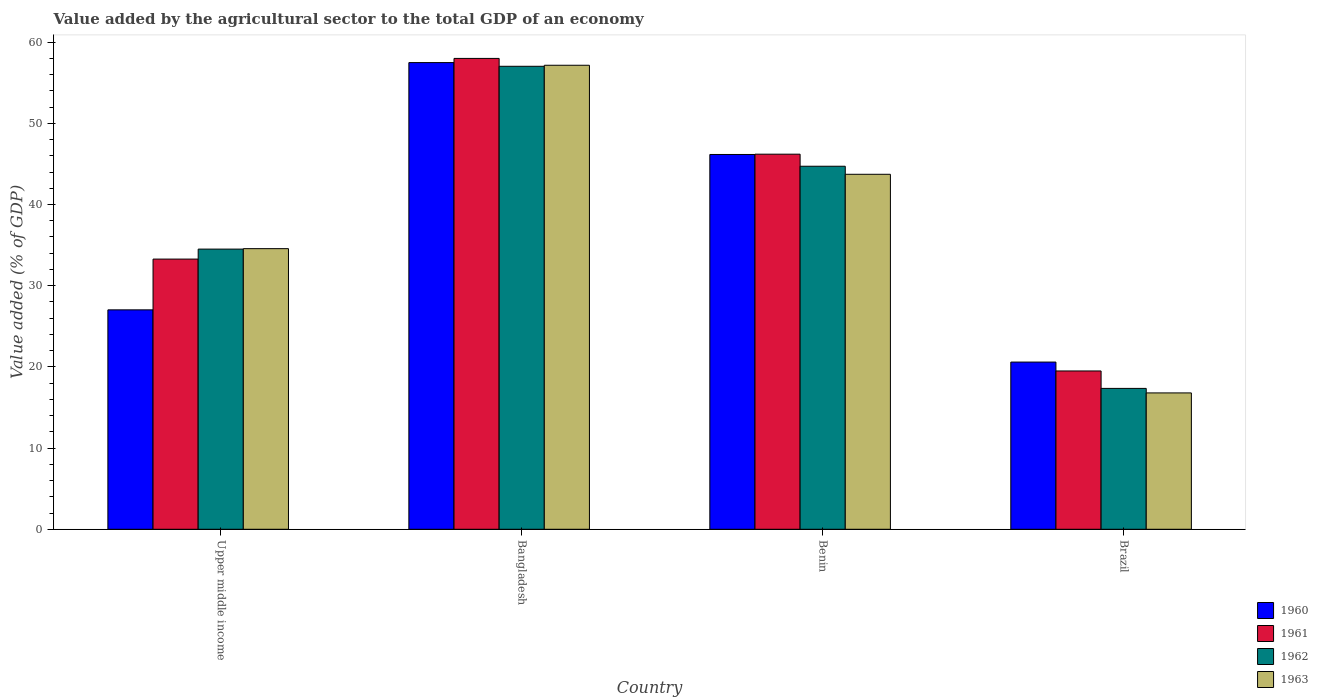Are the number of bars per tick equal to the number of legend labels?
Offer a very short reply. Yes. Are the number of bars on each tick of the X-axis equal?
Provide a succinct answer. Yes. How many bars are there on the 3rd tick from the left?
Your response must be concise. 4. What is the label of the 2nd group of bars from the left?
Offer a terse response. Bangladesh. In how many cases, is the number of bars for a given country not equal to the number of legend labels?
Offer a very short reply. 0. What is the value added by the agricultural sector to the total GDP in 1960 in Brazil?
Your answer should be very brief. 20.59. Across all countries, what is the maximum value added by the agricultural sector to the total GDP in 1963?
Keep it short and to the point. 57.15. Across all countries, what is the minimum value added by the agricultural sector to the total GDP in 1961?
Offer a terse response. 19.5. In which country was the value added by the agricultural sector to the total GDP in 1961 minimum?
Ensure brevity in your answer.  Brazil. What is the total value added by the agricultural sector to the total GDP in 1961 in the graph?
Provide a short and direct response. 156.95. What is the difference between the value added by the agricultural sector to the total GDP in 1963 in Brazil and that in Upper middle income?
Keep it short and to the point. -17.77. What is the difference between the value added by the agricultural sector to the total GDP in 1961 in Benin and the value added by the agricultural sector to the total GDP in 1962 in Brazil?
Keep it short and to the point. 28.84. What is the average value added by the agricultural sector to the total GDP in 1963 per country?
Your response must be concise. 38.05. What is the difference between the value added by the agricultural sector to the total GDP of/in 1962 and value added by the agricultural sector to the total GDP of/in 1961 in Bangladesh?
Your answer should be compact. -0.97. What is the ratio of the value added by the agricultural sector to the total GDP in 1963 in Bangladesh to that in Brazil?
Keep it short and to the point. 3.4. Is the value added by the agricultural sector to the total GDP in 1963 in Bangladesh less than that in Benin?
Keep it short and to the point. No. What is the difference between the highest and the second highest value added by the agricultural sector to the total GDP in 1960?
Your response must be concise. 30.45. What is the difference between the highest and the lowest value added by the agricultural sector to the total GDP in 1963?
Offer a very short reply. 40.35. In how many countries, is the value added by the agricultural sector to the total GDP in 1960 greater than the average value added by the agricultural sector to the total GDP in 1960 taken over all countries?
Offer a very short reply. 2. Is the sum of the value added by the agricultural sector to the total GDP in 1963 in Bangladesh and Upper middle income greater than the maximum value added by the agricultural sector to the total GDP in 1961 across all countries?
Ensure brevity in your answer.  Yes. What does the 4th bar from the right in Benin represents?
Ensure brevity in your answer.  1960. Is it the case that in every country, the sum of the value added by the agricultural sector to the total GDP in 1963 and value added by the agricultural sector to the total GDP in 1961 is greater than the value added by the agricultural sector to the total GDP in 1960?
Your answer should be compact. Yes. How many bars are there?
Give a very brief answer. 16. Are all the bars in the graph horizontal?
Give a very brief answer. No. How many countries are there in the graph?
Provide a succinct answer. 4. What is the difference between two consecutive major ticks on the Y-axis?
Provide a short and direct response. 10. Does the graph contain any zero values?
Keep it short and to the point. No. What is the title of the graph?
Keep it short and to the point. Value added by the agricultural sector to the total GDP of an economy. Does "1960" appear as one of the legend labels in the graph?
Offer a terse response. Yes. What is the label or title of the Y-axis?
Ensure brevity in your answer.  Value added (% of GDP). What is the Value added (% of GDP) of 1960 in Upper middle income?
Offer a very short reply. 27.02. What is the Value added (% of GDP) of 1961 in Upper middle income?
Offer a very short reply. 33.27. What is the Value added (% of GDP) in 1962 in Upper middle income?
Your answer should be very brief. 34.5. What is the Value added (% of GDP) in 1963 in Upper middle income?
Provide a short and direct response. 34.56. What is the Value added (% of GDP) in 1960 in Bangladesh?
Provide a short and direct response. 57.47. What is the Value added (% of GDP) in 1961 in Bangladesh?
Offer a very short reply. 57.99. What is the Value added (% of GDP) of 1962 in Bangladesh?
Your answer should be compact. 57.02. What is the Value added (% of GDP) of 1963 in Bangladesh?
Give a very brief answer. 57.15. What is the Value added (% of GDP) of 1960 in Benin?
Your response must be concise. 46.16. What is the Value added (% of GDP) in 1961 in Benin?
Ensure brevity in your answer.  46.19. What is the Value added (% of GDP) of 1962 in Benin?
Offer a terse response. 44.71. What is the Value added (% of GDP) of 1963 in Benin?
Your response must be concise. 43.72. What is the Value added (% of GDP) in 1960 in Brazil?
Your answer should be compact. 20.59. What is the Value added (% of GDP) in 1961 in Brazil?
Your answer should be compact. 19.5. What is the Value added (% of GDP) in 1962 in Brazil?
Offer a very short reply. 17.35. What is the Value added (% of GDP) of 1963 in Brazil?
Provide a succinct answer. 16.79. Across all countries, what is the maximum Value added (% of GDP) of 1960?
Provide a succinct answer. 57.47. Across all countries, what is the maximum Value added (% of GDP) of 1961?
Make the answer very short. 57.99. Across all countries, what is the maximum Value added (% of GDP) of 1962?
Ensure brevity in your answer.  57.02. Across all countries, what is the maximum Value added (% of GDP) in 1963?
Your response must be concise. 57.15. Across all countries, what is the minimum Value added (% of GDP) of 1960?
Ensure brevity in your answer.  20.59. Across all countries, what is the minimum Value added (% of GDP) of 1961?
Your response must be concise. 19.5. Across all countries, what is the minimum Value added (% of GDP) of 1962?
Provide a succinct answer. 17.35. Across all countries, what is the minimum Value added (% of GDP) in 1963?
Keep it short and to the point. 16.79. What is the total Value added (% of GDP) of 1960 in the graph?
Offer a terse response. 151.25. What is the total Value added (% of GDP) of 1961 in the graph?
Offer a very short reply. 156.95. What is the total Value added (% of GDP) in 1962 in the graph?
Make the answer very short. 153.58. What is the total Value added (% of GDP) in 1963 in the graph?
Provide a succinct answer. 152.22. What is the difference between the Value added (% of GDP) in 1960 in Upper middle income and that in Bangladesh?
Give a very brief answer. -30.45. What is the difference between the Value added (% of GDP) in 1961 in Upper middle income and that in Bangladesh?
Offer a terse response. -24.71. What is the difference between the Value added (% of GDP) of 1962 in Upper middle income and that in Bangladesh?
Offer a terse response. -22.51. What is the difference between the Value added (% of GDP) in 1963 in Upper middle income and that in Bangladesh?
Give a very brief answer. -22.59. What is the difference between the Value added (% of GDP) of 1960 in Upper middle income and that in Benin?
Ensure brevity in your answer.  -19.14. What is the difference between the Value added (% of GDP) in 1961 in Upper middle income and that in Benin?
Provide a short and direct response. -12.92. What is the difference between the Value added (% of GDP) in 1962 in Upper middle income and that in Benin?
Your answer should be compact. -10.21. What is the difference between the Value added (% of GDP) of 1963 in Upper middle income and that in Benin?
Provide a succinct answer. -9.16. What is the difference between the Value added (% of GDP) of 1960 in Upper middle income and that in Brazil?
Offer a terse response. 6.43. What is the difference between the Value added (% of GDP) in 1961 in Upper middle income and that in Brazil?
Offer a very short reply. 13.78. What is the difference between the Value added (% of GDP) in 1962 in Upper middle income and that in Brazil?
Your response must be concise. 17.15. What is the difference between the Value added (% of GDP) of 1963 in Upper middle income and that in Brazil?
Ensure brevity in your answer.  17.77. What is the difference between the Value added (% of GDP) of 1960 in Bangladesh and that in Benin?
Your response must be concise. 11.32. What is the difference between the Value added (% of GDP) of 1961 in Bangladesh and that in Benin?
Keep it short and to the point. 11.79. What is the difference between the Value added (% of GDP) of 1962 in Bangladesh and that in Benin?
Keep it short and to the point. 12.31. What is the difference between the Value added (% of GDP) of 1963 in Bangladesh and that in Benin?
Provide a succinct answer. 13.43. What is the difference between the Value added (% of GDP) of 1960 in Bangladesh and that in Brazil?
Offer a very short reply. 36.88. What is the difference between the Value added (% of GDP) of 1961 in Bangladesh and that in Brazil?
Your answer should be compact. 38.49. What is the difference between the Value added (% of GDP) in 1962 in Bangladesh and that in Brazil?
Give a very brief answer. 39.67. What is the difference between the Value added (% of GDP) of 1963 in Bangladesh and that in Brazil?
Offer a very short reply. 40.35. What is the difference between the Value added (% of GDP) in 1960 in Benin and that in Brazil?
Provide a succinct answer. 25.56. What is the difference between the Value added (% of GDP) of 1961 in Benin and that in Brazil?
Provide a short and direct response. 26.7. What is the difference between the Value added (% of GDP) in 1962 in Benin and that in Brazil?
Give a very brief answer. 27.36. What is the difference between the Value added (% of GDP) in 1963 in Benin and that in Brazil?
Ensure brevity in your answer.  26.92. What is the difference between the Value added (% of GDP) in 1960 in Upper middle income and the Value added (% of GDP) in 1961 in Bangladesh?
Your answer should be very brief. -30.97. What is the difference between the Value added (% of GDP) in 1960 in Upper middle income and the Value added (% of GDP) in 1962 in Bangladesh?
Make the answer very short. -30. What is the difference between the Value added (% of GDP) in 1960 in Upper middle income and the Value added (% of GDP) in 1963 in Bangladesh?
Your answer should be very brief. -30.12. What is the difference between the Value added (% of GDP) of 1961 in Upper middle income and the Value added (% of GDP) of 1962 in Bangladesh?
Your answer should be very brief. -23.74. What is the difference between the Value added (% of GDP) of 1961 in Upper middle income and the Value added (% of GDP) of 1963 in Bangladesh?
Provide a succinct answer. -23.87. What is the difference between the Value added (% of GDP) in 1962 in Upper middle income and the Value added (% of GDP) in 1963 in Bangladesh?
Your answer should be very brief. -22.64. What is the difference between the Value added (% of GDP) in 1960 in Upper middle income and the Value added (% of GDP) in 1961 in Benin?
Offer a terse response. -19.17. What is the difference between the Value added (% of GDP) of 1960 in Upper middle income and the Value added (% of GDP) of 1962 in Benin?
Your answer should be compact. -17.69. What is the difference between the Value added (% of GDP) of 1960 in Upper middle income and the Value added (% of GDP) of 1963 in Benin?
Make the answer very short. -16.7. What is the difference between the Value added (% of GDP) of 1961 in Upper middle income and the Value added (% of GDP) of 1962 in Benin?
Make the answer very short. -11.43. What is the difference between the Value added (% of GDP) of 1961 in Upper middle income and the Value added (% of GDP) of 1963 in Benin?
Your response must be concise. -10.44. What is the difference between the Value added (% of GDP) of 1962 in Upper middle income and the Value added (% of GDP) of 1963 in Benin?
Make the answer very short. -9.21. What is the difference between the Value added (% of GDP) in 1960 in Upper middle income and the Value added (% of GDP) in 1961 in Brazil?
Provide a succinct answer. 7.53. What is the difference between the Value added (% of GDP) in 1960 in Upper middle income and the Value added (% of GDP) in 1962 in Brazil?
Your response must be concise. 9.67. What is the difference between the Value added (% of GDP) in 1960 in Upper middle income and the Value added (% of GDP) in 1963 in Brazil?
Your response must be concise. 10.23. What is the difference between the Value added (% of GDP) in 1961 in Upper middle income and the Value added (% of GDP) in 1962 in Brazil?
Your answer should be compact. 15.92. What is the difference between the Value added (% of GDP) of 1961 in Upper middle income and the Value added (% of GDP) of 1963 in Brazil?
Provide a short and direct response. 16.48. What is the difference between the Value added (% of GDP) in 1962 in Upper middle income and the Value added (% of GDP) in 1963 in Brazil?
Ensure brevity in your answer.  17.71. What is the difference between the Value added (% of GDP) in 1960 in Bangladesh and the Value added (% of GDP) in 1961 in Benin?
Offer a very short reply. 11.28. What is the difference between the Value added (% of GDP) of 1960 in Bangladesh and the Value added (% of GDP) of 1962 in Benin?
Your answer should be very brief. 12.77. What is the difference between the Value added (% of GDP) in 1960 in Bangladesh and the Value added (% of GDP) in 1963 in Benin?
Offer a very short reply. 13.76. What is the difference between the Value added (% of GDP) in 1961 in Bangladesh and the Value added (% of GDP) in 1962 in Benin?
Provide a short and direct response. 13.28. What is the difference between the Value added (% of GDP) of 1961 in Bangladesh and the Value added (% of GDP) of 1963 in Benin?
Offer a terse response. 14.27. What is the difference between the Value added (% of GDP) of 1962 in Bangladesh and the Value added (% of GDP) of 1963 in Benin?
Make the answer very short. 13.3. What is the difference between the Value added (% of GDP) of 1960 in Bangladesh and the Value added (% of GDP) of 1961 in Brazil?
Your answer should be compact. 37.98. What is the difference between the Value added (% of GDP) in 1960 in Bangladesh and the Value added (% of GDP) in 1962 in Brazil?
Make the answer very short. 40.12. What is the difference between the Value added (% of GDP) in 1960 in Bangladesh and the Value added (% of GDP) in 1963 in Brazil?
Provide a short and direct response. 40.68. What is the difference between the Value added (% of GDP) of 1961 in Bangladesh and the Value added (% of GDP) of 1962 in Brazil?
Offer a terse response. 40.64. What is the difference between the Value added (% of GDP) in 1961 in Bangladesh and the Value added (% of GDP) in 1963 in Brazil?
Offer a very short reply. 41.19. What is the difference between the Value added (% of GDP) of 1962 in Bangladesh and the Value added (% of GDP) of 1963 in Brazil?
Give a very brief answer. 40.22. What is the difference between the Value added (% of GDP) in 1960 in Benin and the Value added (% of GDP) in 1961 in Brazil?
Your answer should be very brief. 26.66. What is the difference between the Value added (% of GDP) of 1960 in Benin and the Value added (% of GDP) of 1962 in Brazil?
Offer a very short reply. 28.81. What is the difference between the Value added (% of GDP) of 1960 in Benin and the Value added (% of GDP) of 1963 in Brazil?
Offer a very short reply. 29.36. What is the difference between the Value added (% of GDP) in 1961 in Benin and the Value added (% of GDP) in 1962 in Brazil?
Your answer should be very brief. 28.84. What is the difference between the Value added (% of GDP) of 1961 in Benin and the Value added (% of GDP) of 1963 in Brazil?
Provide a succinct answer. 29.4. What is the difference between the Value added (% of GDP) in 1962 in Benin and the Value added (% of GDP) in 1963 in Brazil?
Provide a succinct answer. 27.92. What is the average Value added (% of GDP) in 1960 per country?
Your response must be concise. 37.81. What is the average Value added (% of GDP) of 1961 per country?
Keep it short and to the point. 39.24. What is the average Value added (% of GDP) in 1962 per country?
Make the answer very short. 38.4. What is the average Value added (% of GDP) of 1963 per country?
Offer a terse response. 38.05. What is the difference between the Value added (% of GDP) in 1960 and Value added (% of GDP) in 1961 in Upper middle income?
Your response must be concise. -6.25. What is the difference between the Value added (% of GDP) of 1960 and Value added (% of GDP) of 1962 in Upper middle income?
Your answer should be compact. -7.48. What is the difference between the Value added (% of GDP) of 1960 and Value added (% of GDP) of 1963 in Upper middle income?
Ensure brevity in your answer.  -7.54. What is the difference between the Value added (% of GDP) in 1961 and Value added (% of GDP) in 1962 in Upper middle income?
Provide a short and direct response. -1.23. What is the difference between the Value added (% of GDP) in 1961 and Value added (% of GDP) in 1963 in Upper middle income?
Provide a succinct answer. -1.29. What is the difference between the Value added (% of GDP) of 1962 and Value added (% of GDP) of 1963 in Upper middle income?
Offer a very short reply. -0.06. What is the difference between the Value added (% of GDP) of 1960 and Value added (% of GDP) of 1961 in Bangladesh?
Make the answer very short. -0.51. What is the difference between the Value added (% of GDP) in 1960 and Value added (% of GDP) in 1962 in Bangladesh?
Offer a terse response. 0.46. What is the difference between the Value added (% of GDP) in 1960 and Value added (% of GDP) in 1963 in Bangladesh?
Your answer should be very brief. 0.33. What is the difference between the Value added (% of GDP) in 1961 and Value added (% of GDP) in 1962 in Bangladesh?
Your answer should be compact. 0.97. What is the difference between the Value added (% of GDP) of 1961 and Value added (% of GDP) of 1963 in Bangladesh?
Give a very brief answer. 0.84. What is the difference between the Value added (% of GDP) in 1962 and Value added (% of GDP) in 1963 in Bangladesh?
Offer a terse response. -0.13. What is the difference between the Value added (% of GDP) of 1960 and Value added (% of GDP) of 1961 in Benin?
Ensure brevity in your answer.  -0.04. What is the difference between the Value added (% of GDP) of 1960 and Value added (% of GDP) of 1962 in Benin?
Provide a succinct answer. 1.45. What is the difference between the Value added (% of GDP) in 1960 and Value added (% of GDP) in 1963 in Benin?
Give a very brief answer. 2.44. What is the difference between the Value added (% of GDP) in 1961 and Value added (% of GDP) in 1962 in Benin?
Make the answer very short. 1.48. What is the difference between the Value added (% of GDP) in 1961 and Value added (% of GDP) in 1963 in Benin?
Provide a short and direct response. 2.48. What is the difference between the Value added (% of GDP) in 1962 and Value added (% of GDP) in 1963 in Benin?
Offer a terse response. 0.99. What is the difference between the Value added (% of GDP) in 1960 and Value added (% of GDP) in 1961 in Brazil?
Your answer should be very brief. 1.1. What is the difference between the Value added (% of GDP) in 1960 and Value added (% of GDP) in 1962 in Brazil?
Your response must be concise. 3.24. What is the difference between the Value added (% of GDP) in 1960 and Value added (% of GDP) in 1963 in Brazil?
Provide a short and direct response. 3.8. What is the difference between the Value added (% of GDP) of 1961 and Value added (% of GDP) of 1962 in Brazil?
Your response must be concise. 2.15. What is the difference between the Value added (% of GDP) of 1961 and Value added (% of GDP) of 1963 in Brazil?
Provide a succinct answer. 2.7. What is the difference between the Value added (% of GDP) of 1962 and Value added (% of GDP) of 1963 in Brazil?
Give a very brief answer. 0.56. What is the ratio of the Value added (% of GDP) of 1960 in Upper middle income to that in Bangladesh?
Give a very brief answer. 0.47. What is the ratio of the Value added (% of GDP) of 1961 in Upper middle income to that in Bangladesh?
Provide a succinct answer. 0.57. What is the ratio of the Value added (% of GDP) of 1962 in Upper middle income to that in Bangladesh?
Provide a succinct answer. 0.61. What is the ratio of the Value added (% of GDP) in 1963 in Upper middle income to that in Bangladesh?
Your answer should be compact. 0.6. What is the ratio of the Value added (% of GDP) in 1960 in Upper middle income to that in Benin?
Give a very brief answer. 0.59. What is the ratio of the Value added (% of GDP) in 1961 in Upper middle income to that in Benin?
Offer a terse response. 0.72. What is the ratio of the Value added (% of GDP) of 1962 in Upper middle income to that in Benin?
Your answer should be compact. 0.77. What is the ratio of the Value added (% of GDP) in 1963 in Upper middle income to that in Benin?
Give a very brief answer. 0.79. What is the ratio of the Value added (% of GDP) of 1960 in Upper middle income to that in Brazil?
Provide a short and direct response. 1.31. What is the ratio of the Value added (% of GDP) in 1961 in Upper middle income to that in Brazil?
Offer a very short reply. 1.71. What is the ratio of the Value added (% of GDP) of 1962 in Upper middle income to that in Brazil?
Provide a succinct answer. 1.99. What is the ratio of the Value added (% of GDP) of 1963 in Upper middle income to that in Brazil?
Your answer should be compact. 2.06. What is the ratio of the Value added (% of GDP) of 1960 in Bangladesh to that in Benin?
Provide a succinct answer. 1.25. What is the ratio of the Value added (% of GDP) of 1961 in Bangladesh to that in Benin?
Ensure brevity in your answer.  1.26. What is the ratio of the Value added (% of GDP) of 1962 in Bangladesh to that in Benin?
Ensure brevity in your answer.  1.28. What is the ratio of the Value added (% of GDP) in 1963 in Bangladesh to that in Benin?
Offer a very short reply. 1.31. What is the ratio of the Value added (% of GDP) in 1960 in Bangladesh to that in Brazil?
Make the answer very short. 2.79. What is the ratio of the Value added (% of GDP) in 1961 in Bangladesh to that in Brazil?
Offer a terse response. 2.97. What is the ratio of the Value added (% of GDP) in 1962 in Bangladesh to that in Brazil?
Your answer should be very brief. 3.29. What is the ratio of the Value added (% of GDP) of 1963 in Bangladesh to that in Brazil?
Make the answer very short. 3.4. What is the ratio of the Value added (% of GDP) of 1960 in Benin to that in Brazil?
Offer a very short reply. 2.24. What is the ratio of the Value added (% of GDP) in 1961 in Benin to that in Brazil?
Provide a succinct answer. 2.37. What is the ratio of the Value added (% of GDP) of 1962 in Benin to that in Brazil?
Ensure brevity in your answer.  2.58. What is the ratio of the Value added (% of GDP) in 1963 in Benin to that in Brazil?
Offer a terse response. 2.6. What is the difference between the highest and the second highest Value added (% of GDP) in 1960?
Your response must be concise. 11.32. What is the difference between the highest and the second highest Value added (% of GDP) in 1961?
Give a very brief answer. 11.79. What is the difference between the highest and the second highest Value added (% of GDP) of 1962?
Ensure brevity in your answer.  12.31. What is the difference between the highest and the second highest Value added (% of GDP) of 1963?
Keep it short and to the point. 13.43. What is the difference between the highest and the lowest Value added (% of GDP) in 1960?
Make the answer very short. 36.88. What is the difference between the highest and the lowest Value added (% of GDP) of 1961?
Give a very brief answer. 38.49. What is the difference between the highest and the lowest Value added (% of GDP) of 1962?
Your answer should be very brief. 39.67. What is the difference between the highest and the lowest Value added (% of GDP) of 1963?
Provide a short and direct response. 40.35. 